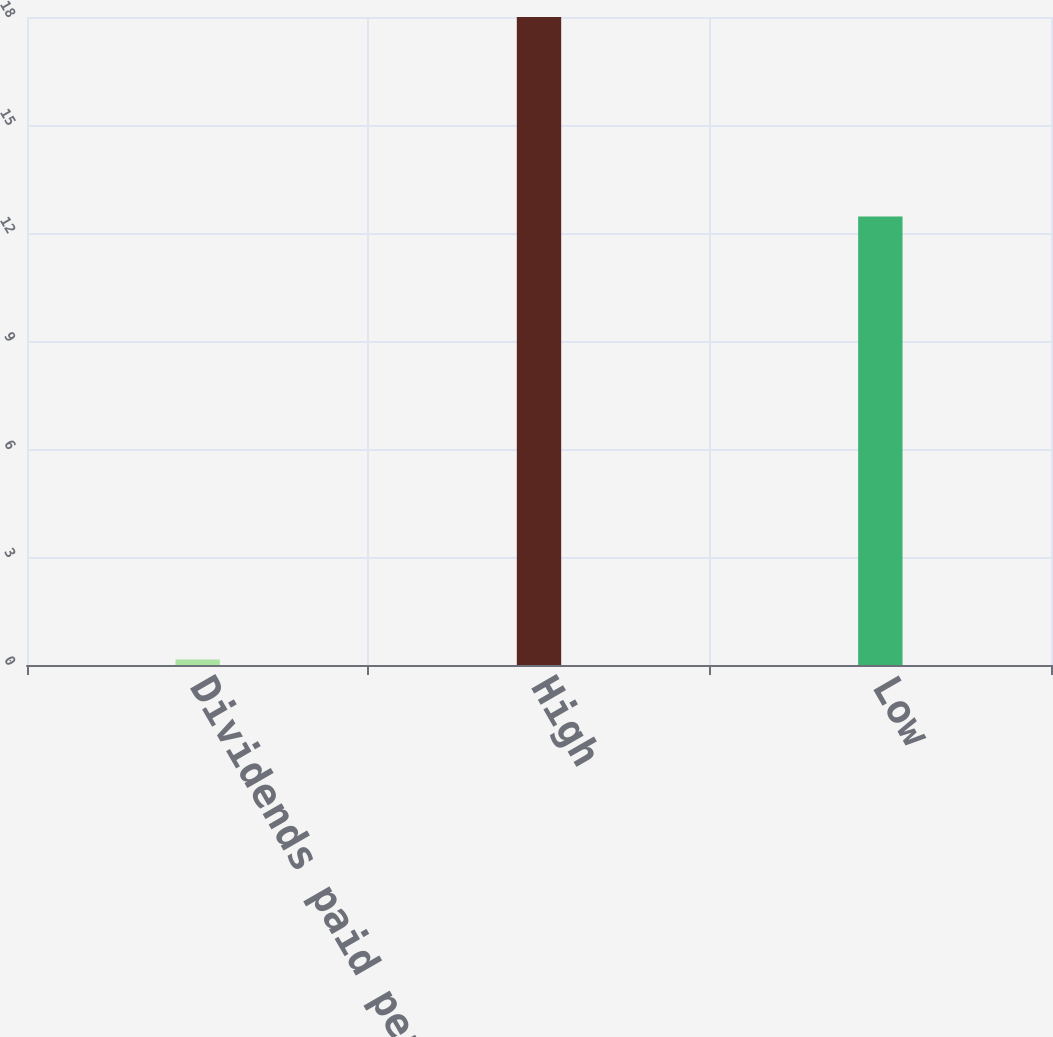Convert chart. <chart><loc_0><loc_0><loc_500><loc_500><bar_chart><fcel>Dividends paid per share<fcel>High<fcel>Low<nl><fcel>0.15<fcel>18<fcel>12.46<nl></chart> 